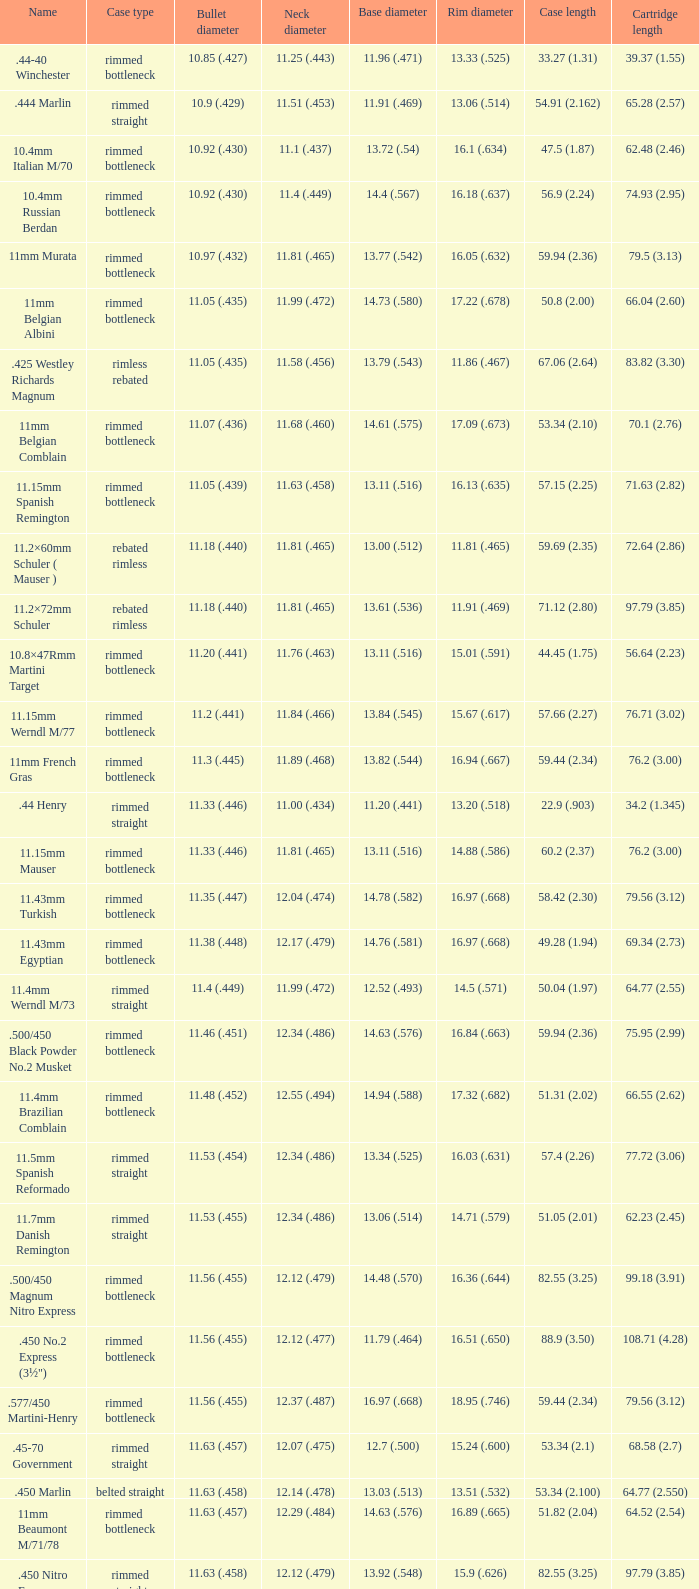Which bullet dimension is referred to as 1 11.4 (.449). 